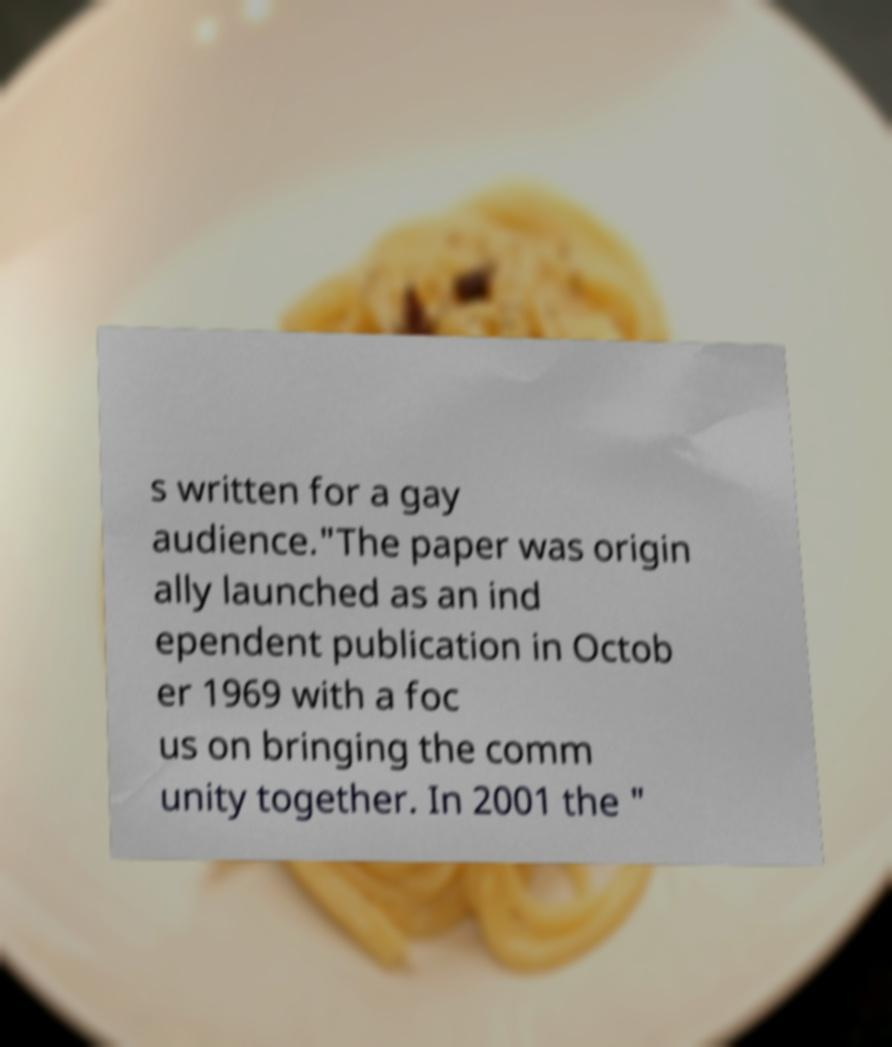What messages or text are displayed in this image? I need them in a readable, typed format. s written for a gay audience."The paper was origin ally launched as an ind ependent publication in Octob er 1969 with a foc us on bringing the comm unity together. In 2001 the " 